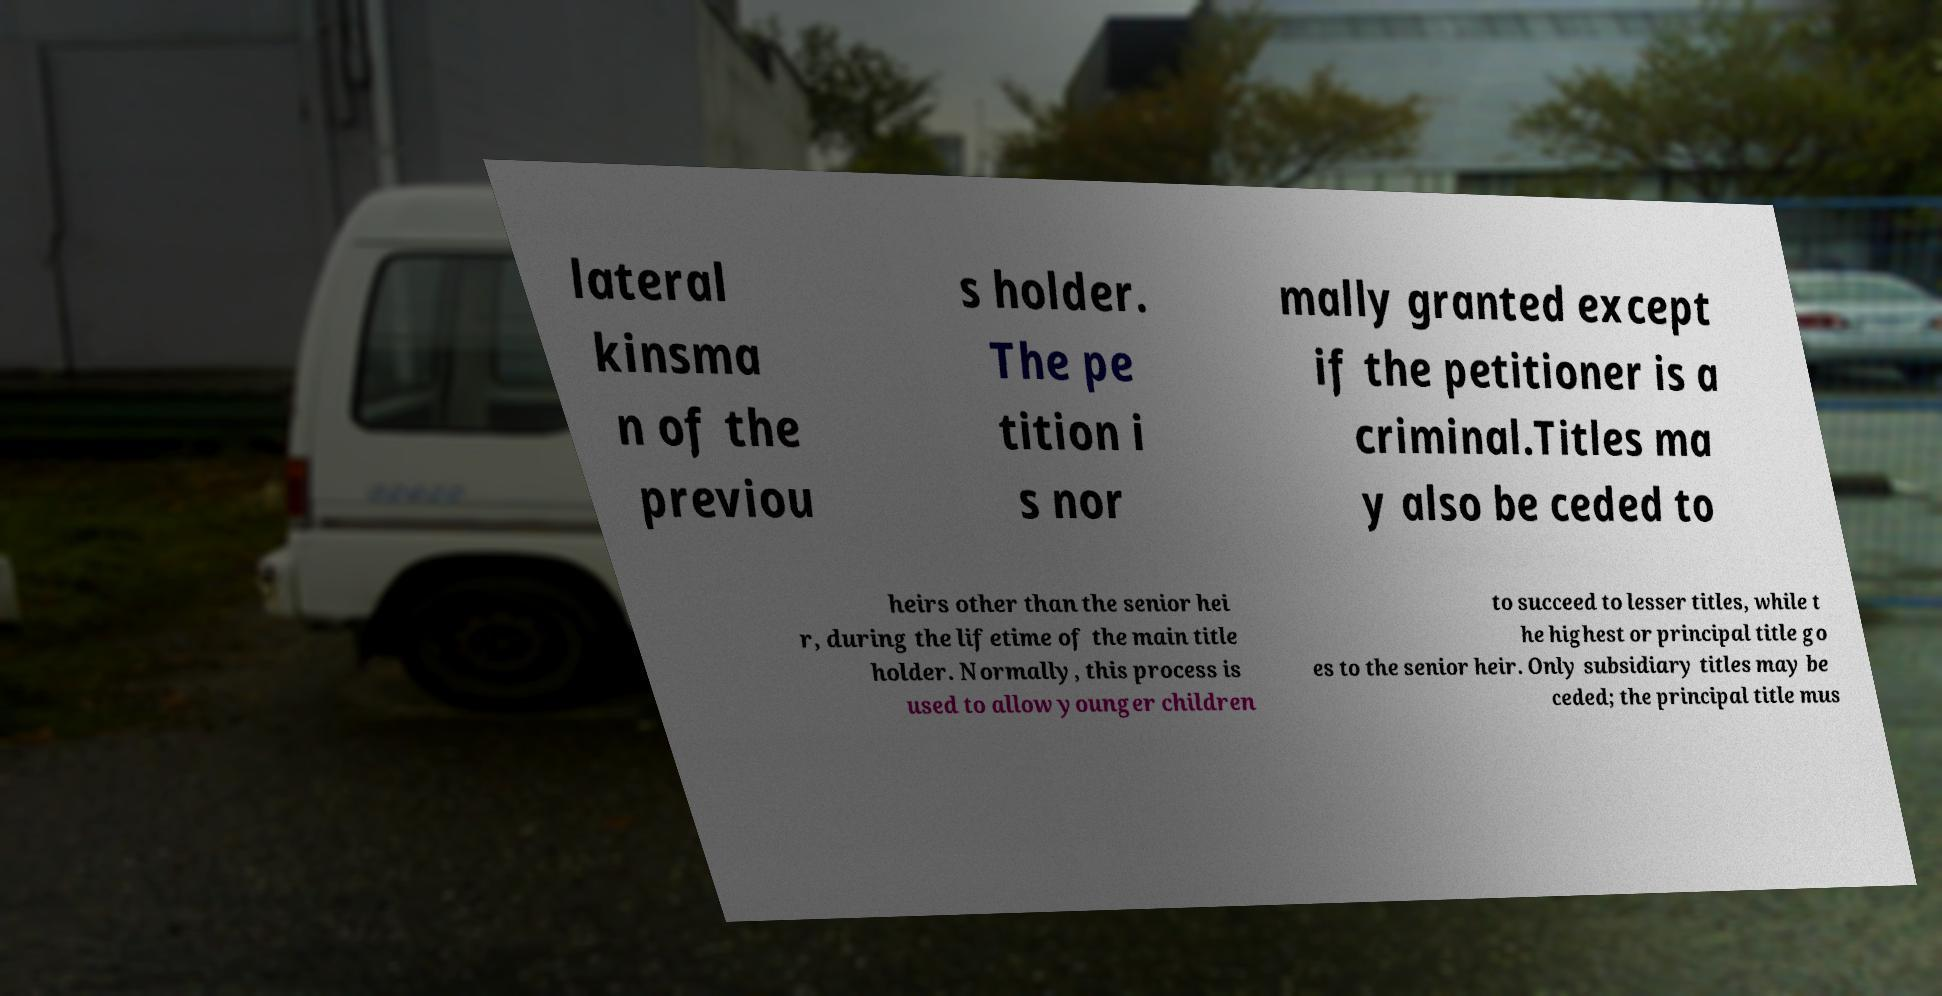What messages or text are displayed in this image? I need them in a readable, typed format. lateral kinsma n of the previou s holder. The pe tition i s nor mally granted except if the petitioner is a criminal.Titles ma y also be ceded to heirs other than the senior hei r, during the lifetime of the main title holder. Normally, this process is used to allow younger children to succeed to lesser titles, while t he highest or principal title go es to the senior heir. Only subsidiary titles may be ceded; the principal title mus 